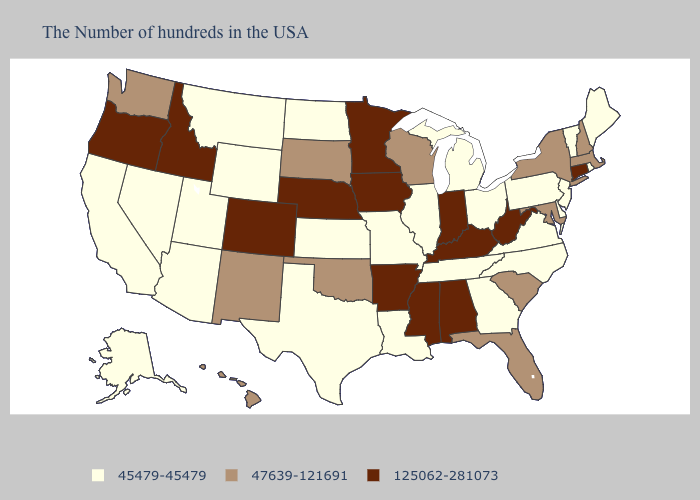Does Arkansas have the highest value in the USA?
Answer briefly. Yes. Which states hav the highest value in the MidWest?
Quick response, please. Indiana, Minnesota, Iowa, Nebraska. Does Louisiana have the lowest value in the USA?
Write a very short answer. Yes. Among the states that border Connecticut , which have the highest value?
Give a very brief answer. Massachusetts, New York. Which states have the lowest value in the West?
Short answer required. Wyoming, Utah, Montana, Arizona, Nevada, California, Alaska. What is the lowest value in the USA?
Give a very brief answer. 45479-45479. Which states have the lowest value in the USA?
Be succinct. Maine, Rhode Island, Vermont, New Jersey, Delaware, Pennsylvania, Virginia, North Carolina, Ohio, Georgia, Michigan, Tennessee, Illinois, Louisiana, Missouri, Kansas, Texas, North Dakota, Wyoming, Utah, Montana, Arizona, Nevada, California, Alaska. Does Colorado have a higher value than Minnesota?
Write a very short answer. No. What is the highest value in states that border California?
Write a very short answer. 125062-281073. Does Pennsylvania have the lowest value in the USA?
Give a very brief answer. Yes. What is the value of Montana?
Keep it brief. 45479-45479. Name the states that have a value in the range 125062-281073?
Answer briefly. Connecticut, West Virginia, Kentucky, Indiana, Alabama, Mississippi, Arkansas, Minnesota, Iowa, Nebraska, Colorado, Idaho, Oregon. Which states have the lowest value in the Northeast?
Give a very brief answer. Maine, Rhode Island, Vermont, New Jersey, Pennsylvania. Name the states that have a value in the range 45479-45479?
Concise answer only. Maine, Rhode Island, Vermont, New Jersey, Delaware, Pennsylvania, Virginia, North Carolina, Ohio, Georgia, Michigan, Tennessee, Illinois, Louisiana, Missouri, Kansas, Texas, North Dakota, Wyoming, Utah, Montana, Arizona, Nevada, California, Alaska. What is the lowest value in the USA?
Quick response, please. 45479-45479. 